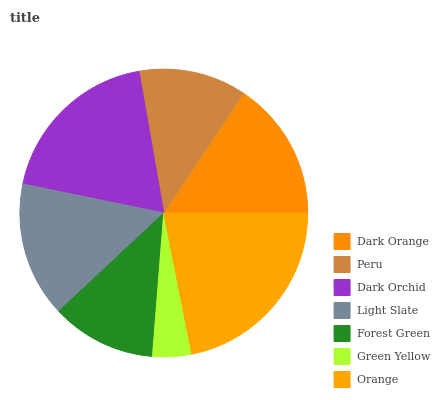Is Green Yellow the minimum?
Answer yes or no. Yes. Is Orange the maximum?
Answer yes or no. Yes. Is Peru the minimum?
Answer yes or no. No. Is Peru the maximum?
Answer yes or no. No. Is Dark Orange greater than Peru?
Answer yes or no. Yes. Is Peru less than Dark Orange?
Answer yes or no. Yes. Is Peru greater than Dark Orange?
Answer yes or no. No. Is Dark Orange less than Peru?
Answer yes or no. No. Is Light Slate the high median?
Answer yes or no. Yes. Is Light Slate the low median?
Answer yes or no. Yes. Is Orange the high median?
Answer yes or no. No. Is Dark Orchid the low median?
Answer yes or no. No. 